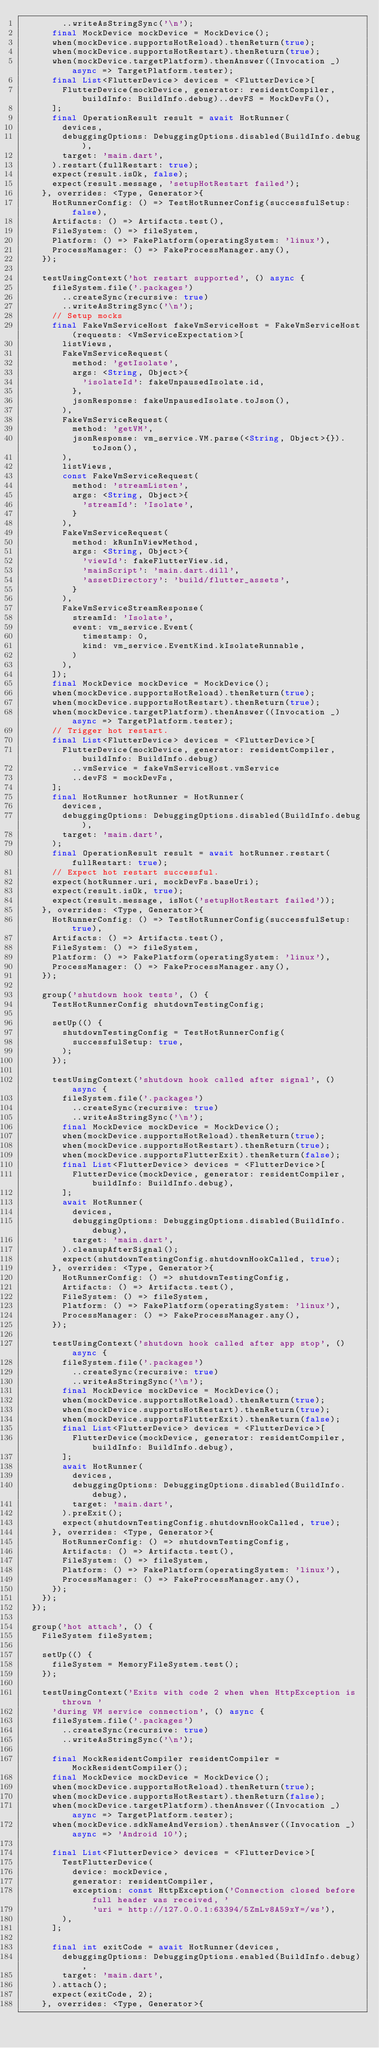<code> <loc_0><loc_0><loc_500><loc_500><_Dart_>        ..writeAsStringSync('\n');
      final MockDevice mockDevice = MockDevice();
      when(mockDevice.supportsHotReload).thenReturn(true);
      when(mockDevice.supportsHotRestart).thenReturn(true);
      when(mockDevice.targetPlatform).thenAnswer((Invocation _) async => TargetPlatform.tester);
      final List<FlutterDevice> devices = <FlutterDevice>[
        FlutterDevice(mockDevice, generator: residentCompiler, buildInfo: BuildInfo.debug)..devFS = MockDevFs(),
      ];
      final OperationResult result = await HotRunner(
        devices,
        debuggingOptions: DebuggingOptions.disabled(BuildInfo.debug),
        target: 'main.dart',
      ).restart(fullRestart: true);
      expect(result.isOk, false);
      expect(result.message, 'setupHotRestart failed');
    }, overrides: <Type, Generator>{
      HotRunnerConfig: () => TestHotRunnerConfig(successfulSetup: false),
      Artifacts: () => Artifacts.test(),
      FileSystem: () => fileSystem,
      Platform: () => FakePlatform(operatingSystem: 'linux'),
      ProcessManager: () => FakeProcessManager.any(),
    });

    testUsingContext('hot restart supported', () async {
      fileSystem.file('.packages')
        ..createSync(recursive: true)
        ..writeAsStringSync('\n');
      // Setup mocks
      final FakeVmServiceHost fakeVmServiceHost = FakeVmServiceHost(requests: <VmServiceExpectation>[
        listViews,
        FakeVmServiceRequest(
          method: 'getIsolate',
          args: <String, Object>{
            'isolateId': fakeUnpausedIsolate.id,
          },
          jsonResponse: fakeUnpausedIsolate.toJson(),
        ),
        FakeVmServiceRequest(
          method: 'getVM',
          jsonResponse: vm_service.VM.parse(<String, Object>{}).toJson(),
        ),
        listViews,
        const FakeVmServiceRequest(
          method: 'streamListen',
          args: <String, Object>{
            'streamId': 'Isolate',
          }
        ),
        FakeVmServiceRequest(
          method: kRunInViewMethod,
          args: <String, Object>{
            'viewId': fakeFlutterView.id,
            'mainScript': 'main.dart.dill',
            'assetDirectory': 'build/flutter_assets',
          }
        ),
        FakeVmServiceStreamResponse(
          streamId: 'Isolate',
          event: vm_service.Event(
            timestamp: 0,
            kind: vm_service.EventKind.kIsolateRunnable,
          )
        ),
      ]);
      final MockDevice mockDevice = MockDevice();
      when(mockDevice.supportsHotReload).thenReturn(true);
      when(mockDevice.supportsHotRestart).thenReturn(true);
      when(mockDevice.targetPlatform).thenAnswer((Invocation _) async => TargetPlatform.tester);
      // Trigger hot restart.
      final List<FlutterDevice> devices = <FlutterDevice>[
        FlutterDevice(mockDevice, generator: residentCompiler, buildInfo: BuildInfo.debug)
          ..vmService = fakeVmServiceHost.vmService
          ..devFS = mockDevFs,
      ];
      final HotRunner hotRunner = HotRunner(
        devices,
        debuggingOptions: DebuggingOptions.disabled(BuildInfo.debug),
        target: 'main.dart',
      );
      final OperationResult result = await hotRunner.restart(fullRestart: true);
      // Expect hot restart successful.
      expect(hotRunner.uri, mockDevFs.baseUri);
      expect(result.isOk, true);
      expect(result.message, isNot('setupHotRestart failed'));
    }, overrides: <Type, Generator>{
      HotRunnerConfig: () => TestHotRunnerConfig(successfulSetup: true),
      Artifacts: () => Artifacts.test(),
      FileSystem: () => fileSystem,
      Platform: () => FakePlatform(operatingSystem: 'linux'),
      ProcessManager: () => FakeProcessManager.any(),
    });

    group('shutdown hook tests', () {
      TestHotRunnerConfig shutdownTestingConfig;

      setUp(() {
        shutdownTestingConfig = TestHotRunnerConfig(
          successfulSetup: true,
        );
      });

      testUsingContext('shutdown hook called after signal', () async {
        fileSystem.file('.packages')
          ..createSync(recursive: true)
          ..writeAsStringSync('\n');
        final MockDevice mockDevice = MockDevice();
        when(mockDevice.supportsHotReload).thenReturn(true);
        when(mockDevice.supportsHotRestart).thenReturn(true);
        when(mockDevice.supportsFlutterExit).thenReturn(false);
        final List<FlutterDevice> devices = <FlutterDevice>[
          FlutterDevice(mockDevice, generator: residentCompiler, buildInfo: BuildInfo.debug),
        ];
        await HotRunner(
          devices,
          debuggingOptions: DebuggingOptions.disabled(BuildInfo.debug),
          target: 'main.dart',
        ).cleanupAfterSignal();
        expect(shutdownTestingConfig.shutdownHookCalled, true);
      }, overrides: <Type, Generator>{
        HotRunnerConfig: () => shutdownTestingConfig,
        Artifacts: () => Artifacts.test(),
        FileSystem: () => fileSystem,
        Platform: () => FakePlatform(operatingSystem: 'linux'),
        ProcessManager: () => FakeProcessManager.any(),
      });

      testUsingContext('shutdown hook called after app stop', () async {
        fileSystem.file('.packages')
          ..createSync(recursive: true)
          ..writeAsStringSync('\n');
        final MockDevice mockDevice = MockDevice();
        when(mockDevice.supportsHotReload).thenReturn(true);
        when(mockDevice.supportsHotRestart).thenReturn(true);
        when(mockDevice.supportsFlutterExit).thenReturn(false);
        final List<FlutterDevice> devices = <FlutterDevice>[
          FlutterDevice(mockDevice, generator: residentCompiler, buildInfo: BuildInfo.debug),
        ];
        await HotRunner(
          devices,
          debuggingOptions: DebuggingOptions.disabled(BuildInfo.debug),
          target: 'main.dart',
        ).preExit();
        expect(shutdownTestingConfig.shutdownHookCalled, true);
      }, overrides: <Type, Generator>{
        HotRunnerConfig: () => shutdownTestingConfig,
        Artifacts: () => Artifacts.test(),
        FileSystem: () => fileSystem,
        Platform: () => FakePlatform(operatingSystem: 'linux'),
        ProcessManager: () => FakeProcessManager.any(),
      });
    });
  });

  group('hot attach', () {
    FileSystem fileSystem;

    setUp(() {
      fileSystem = MemoryFileSystem.test();
    });

    testUsingContext('Exits with code 2 when when HttpException is thrown '
      'during VM service connection', () async {
      fileSystem.file('.packages')
        ..createSync(recursive: true)
        ..writeAsStringSync('\n');

      final MockResidentCompiler residentCompiler = MockResidentCompiler();
      final MockDevice mockDevice = MockDevice();
      when(mockDevice.supportsHotReload).thenReturn(true);
      when(mockDevice.supportsHotRestart).thenReturn(false);
      when(mockDevice.targetPlatform).thenAnswer((Invocation _) async => TargetPlatform.tester);
      when(mockDevice.sdkNameAndVersion).thenAnswer((Invocation _) async => 'Android 10');

      final List<FlutterDevice> devices = <FlutterDevice>[
        TestFlutterDevice(
          device: mockDevice,
          generator: residentCompiler,
          exception: const HttpException('Connection closed before full header was received, '
              'uri = http://127.0.0.1:63394/5ZmLv8A59xY=/ws'),
        ),
      ];

      final int exitCode = await HotRunner(devices,
        debuggingOptions: DebuggingOptions.enabled(BuildInfo.debug),
        target: 'main.dart',
      ).attach();
      expect(exitCode, 2);
    }, overrides: <Type, Generator>{</code> 